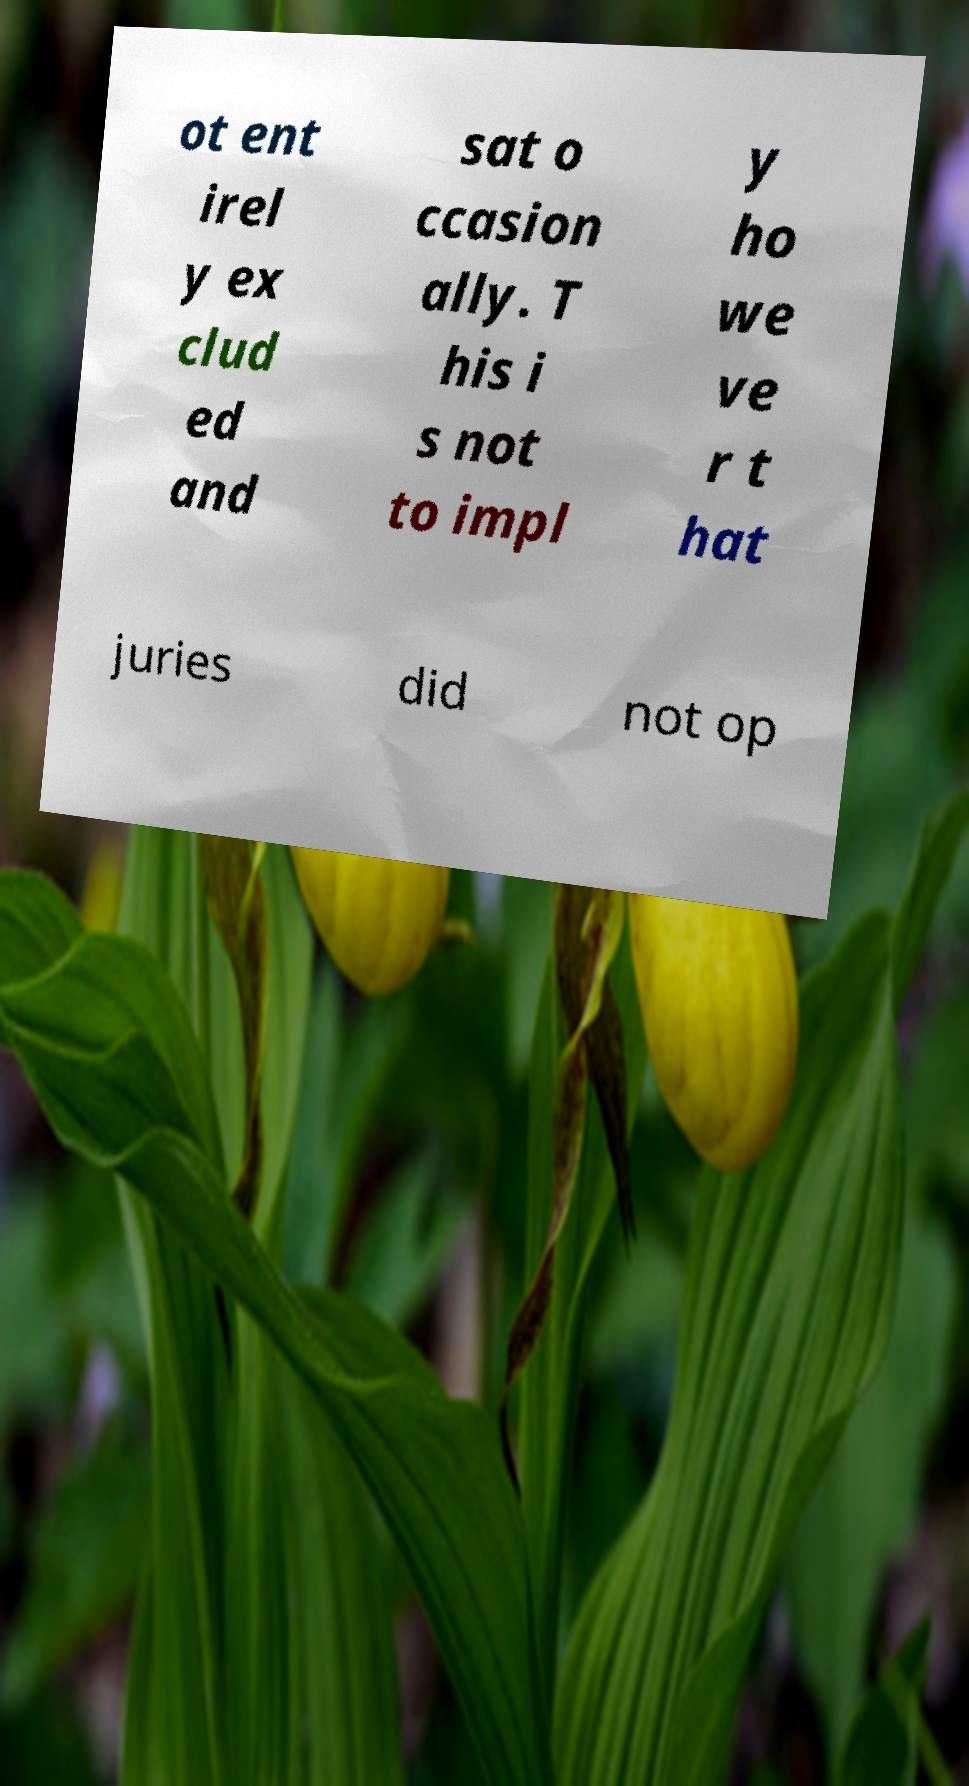For documentation purposes, I need the text within this image transcribed. Could you provide that? ot ent irel y ex clud ed and sat o ccasion ally. T his i s not to impl y ho we ve r t hat juries did not op 